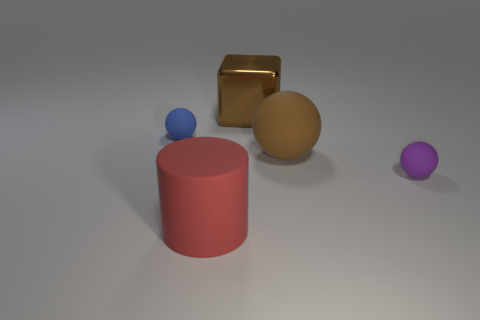Add 5 big cyan cylinders. How many objects exist? 10 Subtract all cylinders. How many objects are left? 4 Add 5 blue objects. How many blue objects exist? 6 Subtract 0 yellow blocks. How many objects are left? 5 Subtract all tiny spheres. Subtract all large yellow rubber cylinders. How many objects are left? 3 Add 5 big cylinders. How many big cylinders are left? 6 